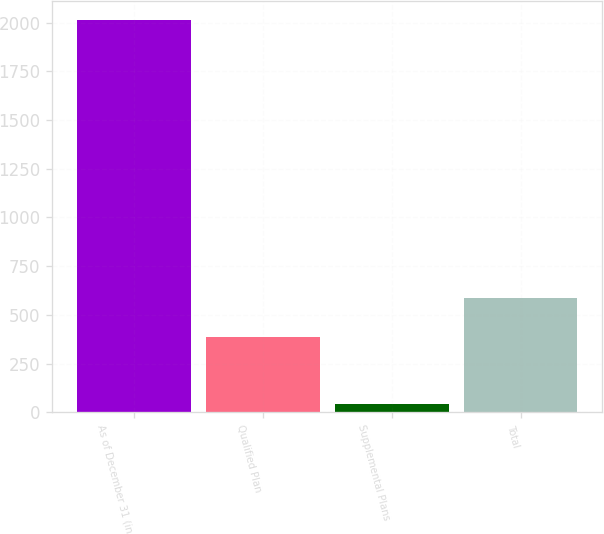<chart> <loc_0><loc_0><loc_500><loc_500><bar_chart><fcel>As of December 31 (in<fcel>Qualified Plan<fcel>Supplemental Plans<fcel>Total<nl><fcel>2012<fcel>387.2<fcel>44<fcel>584<nl></chart> 